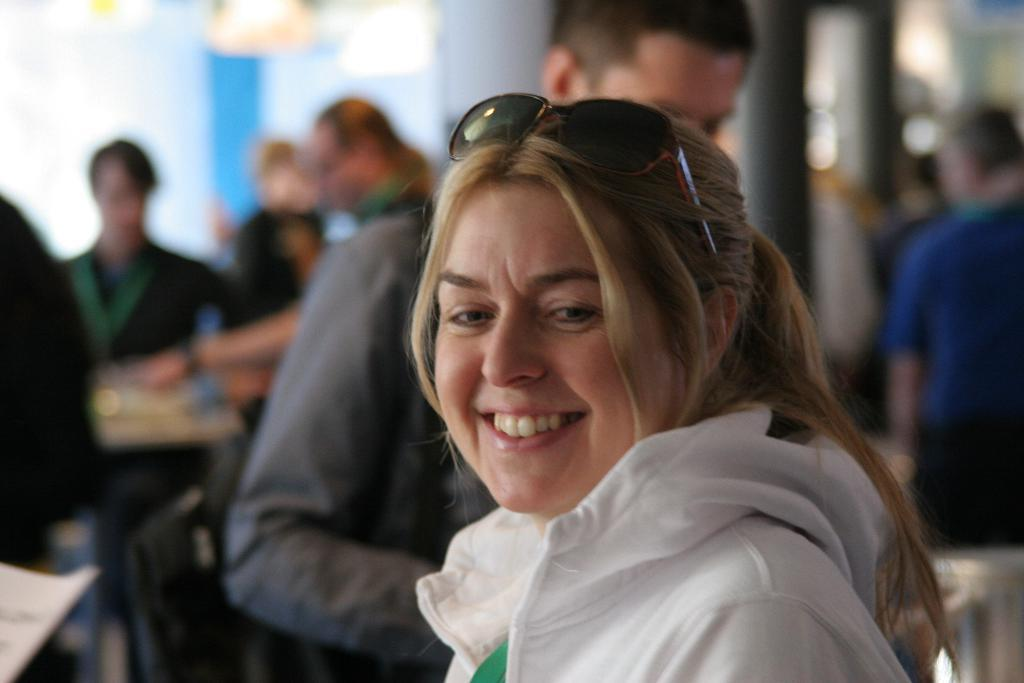What is the main subject of the image? The main subject of the image is a group of people. Can you describe one person in the group? There is a woman in the image who is smiling. What is the woman wearing? The woman is wearing spectacles. What type of ice can be seen melting in the woman's hand in the image? There is no ice present in the image; the woman is not holding anything in her hand. 